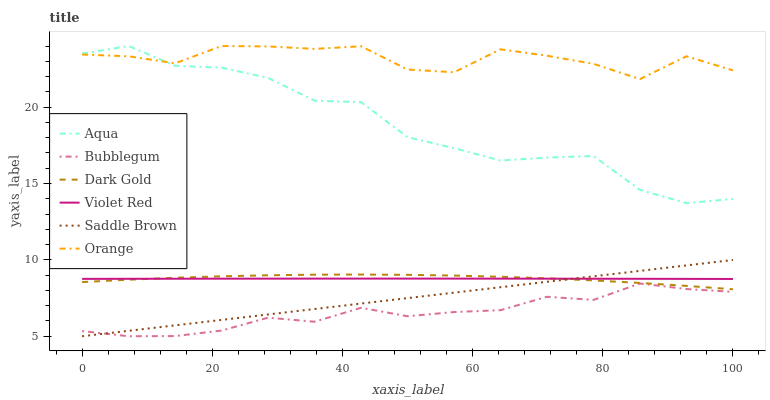Does Bubblegum have the minimum area under the curve?
Answer yes or no. Yes. Does Orange have the maximum area under the curve?
Answer yes or no. Yes. Does Dark Gold have the minimum area under the curve?
Answer yes or no. No. Does Dark Gold have the maximum area under the curve?
Answer yes or no. No. Is Saddle Brown the smoothest?
Answer yes or no. Yes. Is Orange the roughest?
Answer yes or no. Yes. Is Dark Gold the smoothest?
Answer yes or no. No. Is Dark Gold the roughest?
Answer yes or no. No. Does Bubblegum have the lowest value?
Answer yes or no. Yes. Does Dark Gold have the lowest value?
Answer yes or no. No. Does Orange have the highest value?
Answer yes or no. Yes. Does Dark Gold have the highest value?
Answer yes or no. No. Is Saddle Brown less than Orange?
Answer yes or no. Yes. Is Aqua greater than Bubblegum?
Answer yes or no. Yes. Does Orange intersect Aqua?
Answer yes or no. Yes. Is Orange less than Aqua?
Answer yes or no. No. Is Orange greater than Aqua?
Answer yes or no. No. Does Saddle Brown intersect Orange?
Answer yes or no. No. 